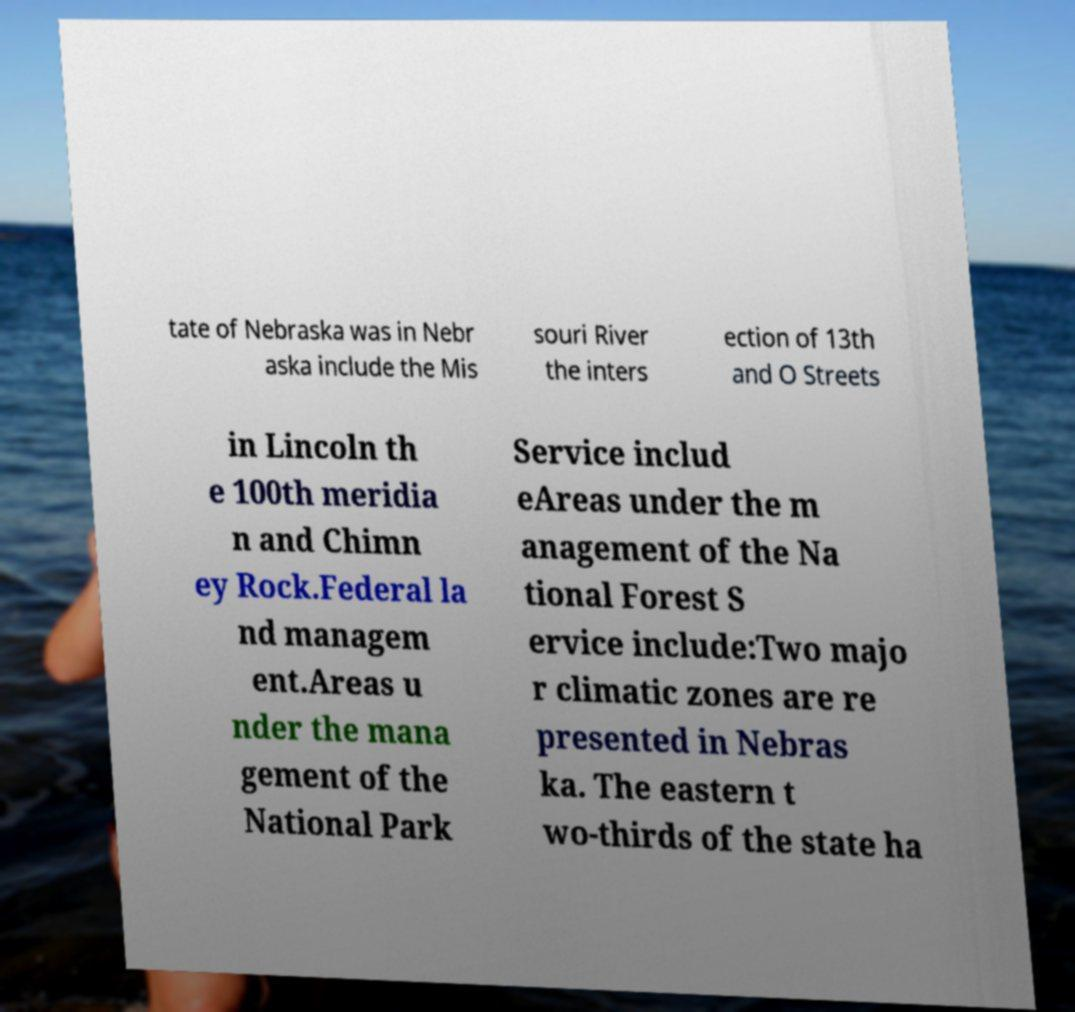For documentation purposes, I need the text within this image transcribed. Could you provide that? tate of Nebraska was in Nebr aska include the Mis souri River the inters ection of 13th and O Streets in Lincoln th e 100th meridia n and Chimn ey Rock.Federal la nd managem ent.Areas u nder the mana gement of the National Park Service includ eAreas under the m anagement of the Na tional Forest S ervice include:Two majo r climatic zones are re presented in Nebras ka. The eastern t wo-thirds of the state ha 